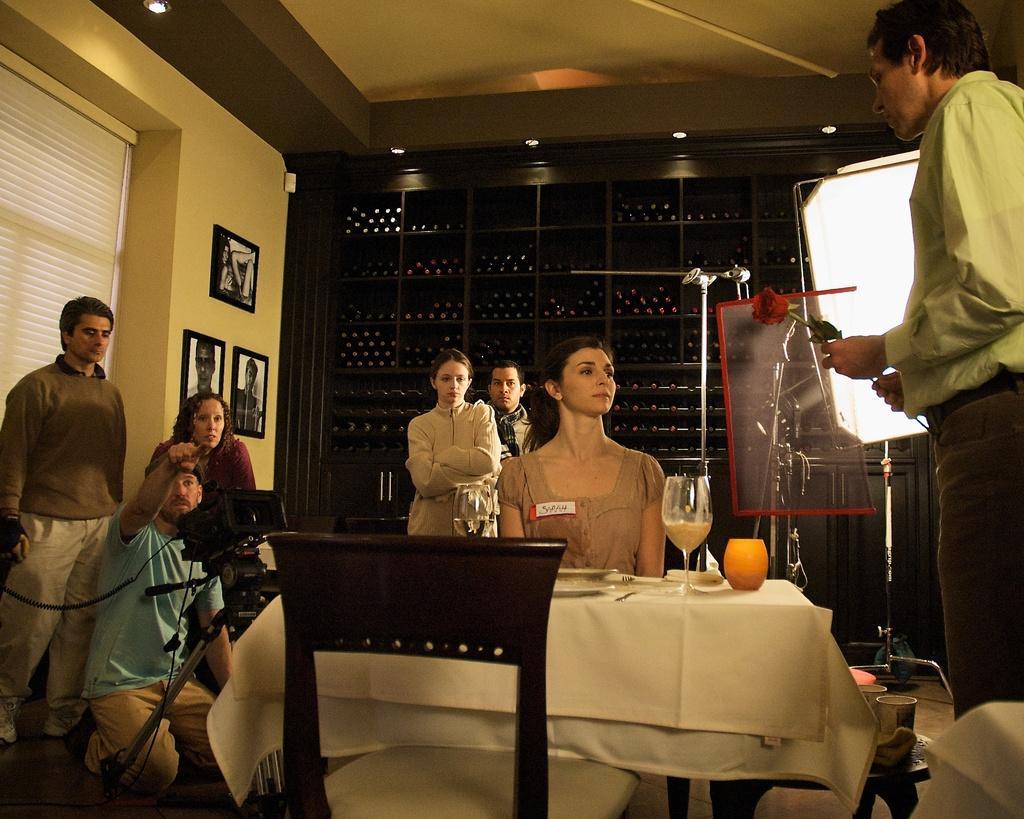Please provide a concise description of this image. There is a man with peach shirt standing on the right of the image and holding a rose flower and in the middle of the image there is a woman sitting behind the table. The is table covered with white cloth and plates and glasses on the table and behind two persons are standing and in the left of the image there are three persons and on the wall there are three photo frames and in the left a person with blue shirt sitting behind the camera. 